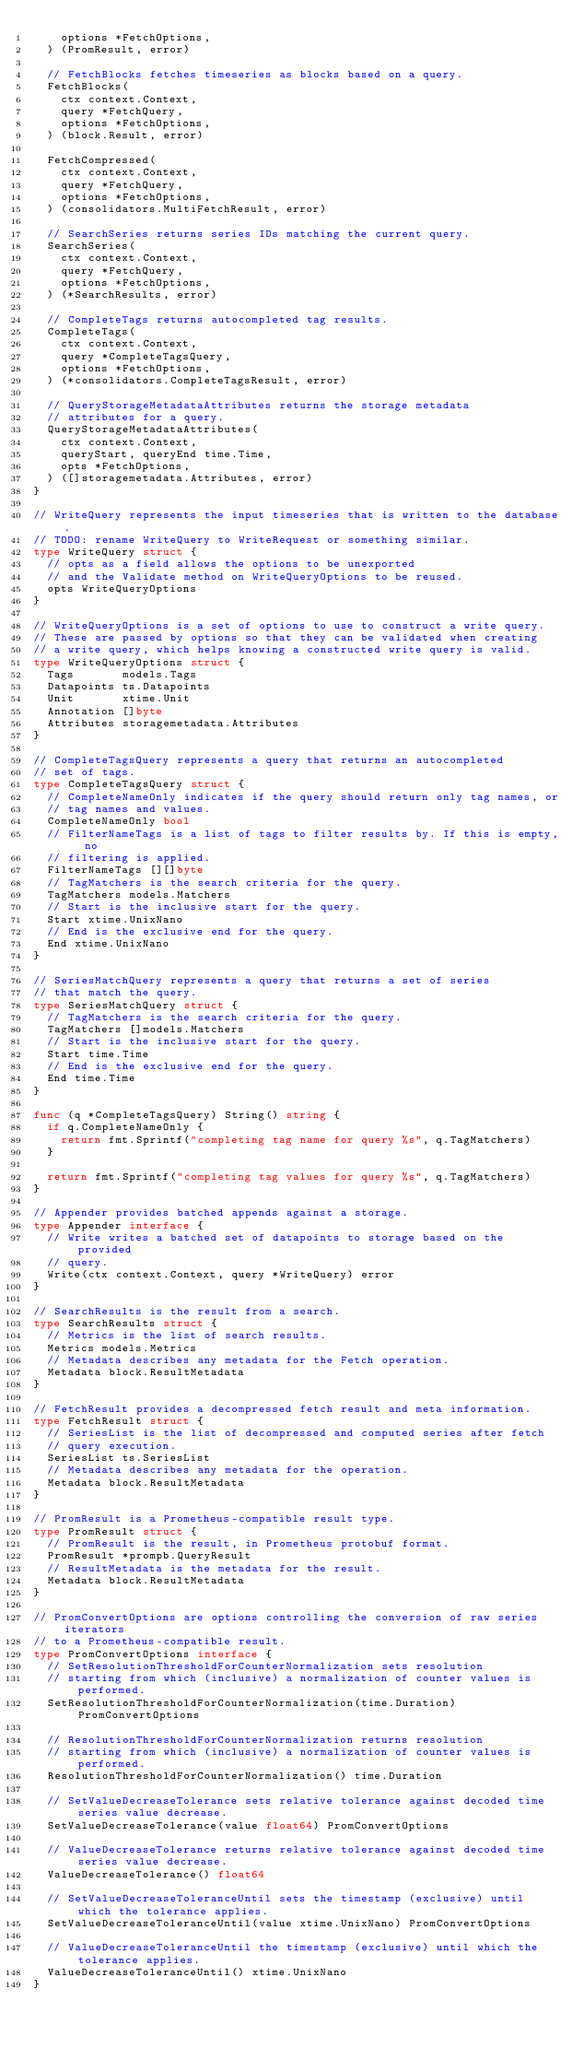Convert code to text. <code><loc_0><loc_0><loc_500><loc_500><_Go_>		options *FetchOptions,
	) (PromResult, error)

	// FetchBlocks fetches timeseries as blocks based on a query.
	FetchBlocks(
		ctx context.Context,
		query *FetchQuery,
		options *FetchOptions,
	) (block.Result, error)

	FetchCompressed(
		ctx context.Context,
		query *FetchQuery,
		options *FetchOptions,
	) (consolidators.MultiFetchResult, error)

	// SearchSeries returns series IDs matching the current query.
	SearchSeries(
		ctx context.Context,
		query *FetchQuery,
		options *FetchOptions,
	) (*SearchResults, error)

	// CompleteTags returns autocompleted tag results.
	CompleteTags(
		ctx context.Context,
		query *CompleteTagsQuery,
		options *FetchOptions,
	) (*consolidators.CompleteTagsResult, error)

	// QueryStorageMetadataAttributes returns the storage metadata
	// attributes for a query.
	QueryStorageMetadataAttributes(
		ctx context.Context,
		queryStart, queryEnd time.Time,
		opts *FetchOptions,
	) ([]storagemetadata.Attributes, error)
}

// WriteQuery represents the input timeseries that is written to the database.
// TODO: rename WriteQuery to WriteRequest or something similar.
type WriteQuery struct {
	// opts as a field allows the options to be unexported
	// and the Validate method on WriteQueryOptions to be reused.
	opts WriteQueryOptions
}

// WriteQueryOptions is a set of options to use to construct a write query.
// These are passed by options so that they can be validated when creating
// a write query, which helps knowing a constructed write query is valid.
type WriteQueryOptions struct {
	Tags       models.Tags
	Datapoints ts.Datapoints
	Unit       xtime.Unit
	Annotation []byte
	Attributes storagemetadata.Attributes
}

// CompleteTagsQuery represents a query that returns an autocompleted
// set of tags.
type CompleteTagsQuery struct {
	// CompleteNameOnly indicates if the query should return only tag names, or
	// tag names and values.
	CompleteNameOnly bool
	// FilterNameTags is a list of tags to filter results by. If this is empty, no
	// filtering is applied.
	FilterNameTags [][]byte
	// TagMatchers is the search criteria for the query.
	TagMatchers models.Matchers
	// Start is the inclusive start for the query.
	Start xtime.UnixNano
	// End is the exclusive end for the query.
	End xtime.UnixNano
}

// SeriesMatchQuery represents a query that returns a set of series
// that match the query.
type SeriesMatchQuery struct {
	// TagMatchers is the search criteria for the query.
	TagMatchers []models.Matchers
	// Start is the inclusive start for the query.
	Start time.Time
	// End is the exclusive end for the query.
	End time.Time
}

func (q *CompleteTagsQuery) String() string {
	if q.CompleteNameOnly {
		return fmt.Sprintf("completing tag name for query %s", q.TagMatchers)
	}

	return fmt.Sprintf("completing tag values for query %s", q.TagMatchers)
}

// Appender provides batched appends against a storage.
type Appender interface {
	// Write writes a batched set of datapoints to storage based on the provided
	// query.
	Write(ctx context.Context, query *WriteQuery) error
}

// SearchResults is the result from a search.
type SearchResults struct {
	// Metrics is the list of search results.
	Metrics models.Metrics
	// Metadata describes any metadata for the Fetch operation.
	Metadata block.ResultMetadata
}

// FetchResult provides a decompressed fetch result and meta information.
type FetchResult struct {
	// SeriesList is the list of decompressed and computed series after fetch
	// query execution.
	SeriesList ts.SeriesList
	// Metadata describes any metadata for the operation.
	Metadata block.ResultMetadata
}

// PromResult is a Prometheus-compatible result type.
type PromResult struct {
	// PromResult is the result, in Prometheus protobuf format.
	PromResult *prompb.QueryResult
	// ResultMetadata is the metadata for the result.
	Metadata block.ResultMetadata
}

// PromConvertOptions are options controlling the conversion of raw series iterators
// to a Prometheus-compatible result.
type PromConvertOptions interface {
	// SetResolutionThresholdForCounterNormalization sets resolution
	// starting from which (inclusive) a normalization of counter values is performed.
	SetResolutionThresholdForCounterNormalization(time.Duration) PromConvertOptions

	// ResolutionThresholdForCounterNormalization returns resolution
	// starting from which (inclusive) a normalization of counter values is performed.
	ResolutionThresholdForCounterNormalization() time.Duration

	// SetValueDecreaseTolerance sets relative tolerance against decoded time series value decrease.
	SetValueDecreaseTolerance(value float64) PromConvertOptions

	// ValueDecreaseTolerance returns relative tolerance against decoded time series value decrease.
	ValueDecreaseTolerance() float64

	// SetValueDecreaseToleranceUntil sets the timestamp (exclusive) until which the tolerance applies.
	SetValueDecreaseToleranceUntil(value xtime.UnixNano) PromConvertOptions

	// ValueDecreaseToleranceUntil the timestamp (exclusive) until which the tolerance applies.
	ValueDecreaseToleranceUntil() xtime.UnixNano
}
</code> 